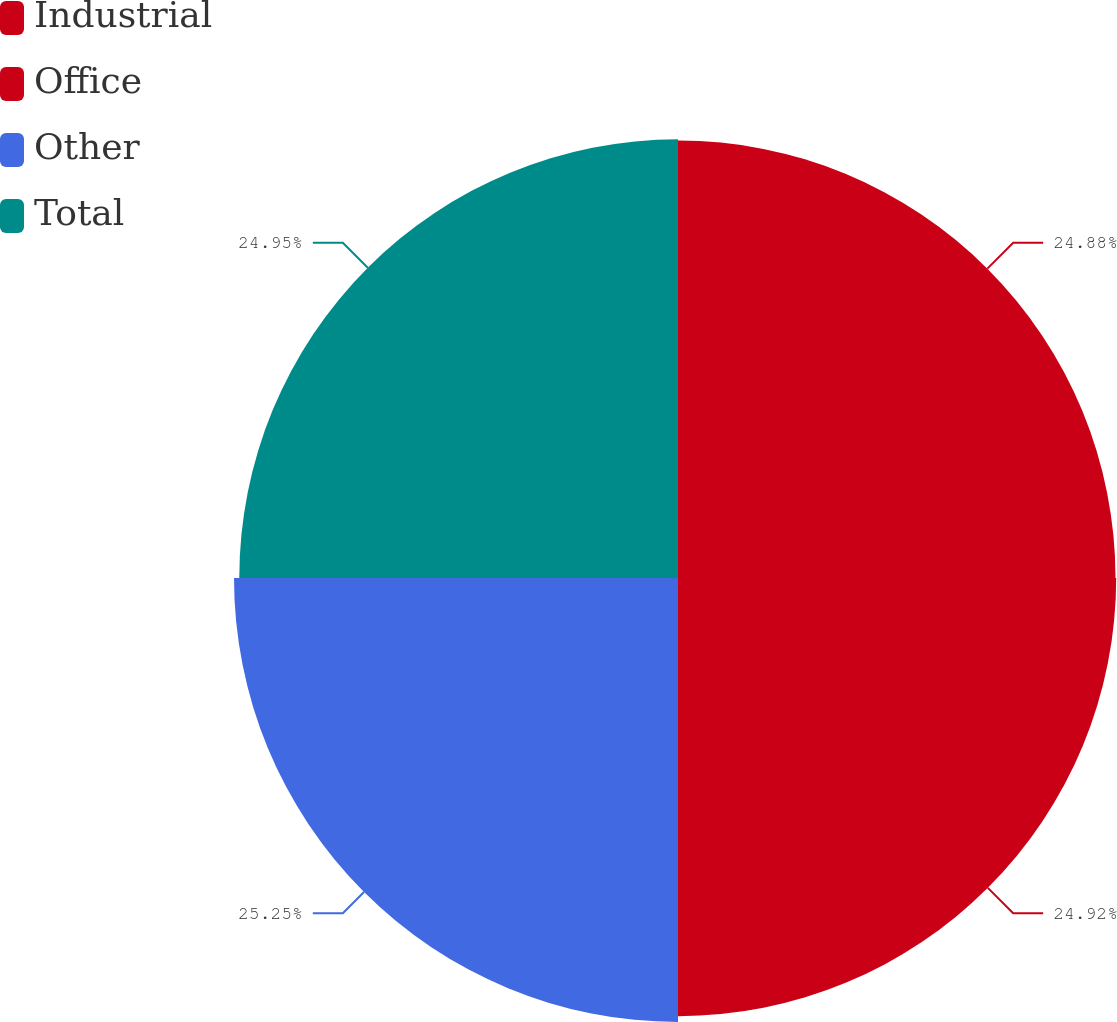Convert chart to OTSL. <chart><loc_0><loc_0><loc_500><loc_500><pie_chart><fcel>Industrial<fcel>Office<fcel>Other<fcel>Total<nl><fcel>24.88%<fcel>24.92%<fcel>25.25%<fcel>24.95%<nl></chart> 